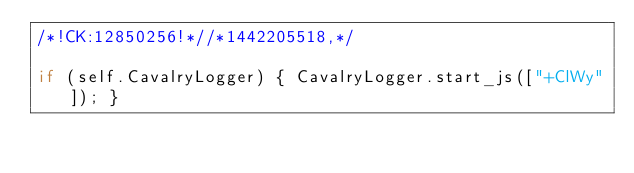<code> <loc_0><loc_0><loc_500><loc_500><_JavaScript_>/*!CK:12850256!*//*1442205518,*/

if (self.CavalryLogger) { CavalryLogger.start_js(["+ClWy"]); }
</code> 